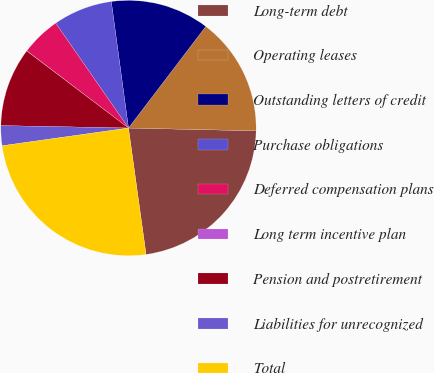Convert chart. <chart><loc_0><loc_0><loc_500><loc_500><pie_chart><fcel>Long-term debt<fcel>Operating leases<fcel>Outstanding letters of credit<fcel>Purchase obligations<fcel>Deferred compensation plans<fcel>Long term incentive plan<fcel>Pension and postretirement<fcel>Liabilities for unrecognized<fcel>Total<nl><fcel>22.45%<fcel>15.0%<fcel>12.5%<fcel>7.51%<fcel>5.01%<fcel>0.02%<fcel>10.01%<fcel>2.52%<fcel>24.98%<nl></chart> 